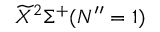Convert formula to latex. <formula><loc_0><loc_0><loc_500><loc_500>\widetilde { X } ^ { 2 } \Sigma ^ { + } ( N ^ { \prime \prime } = 1 )</formula> 